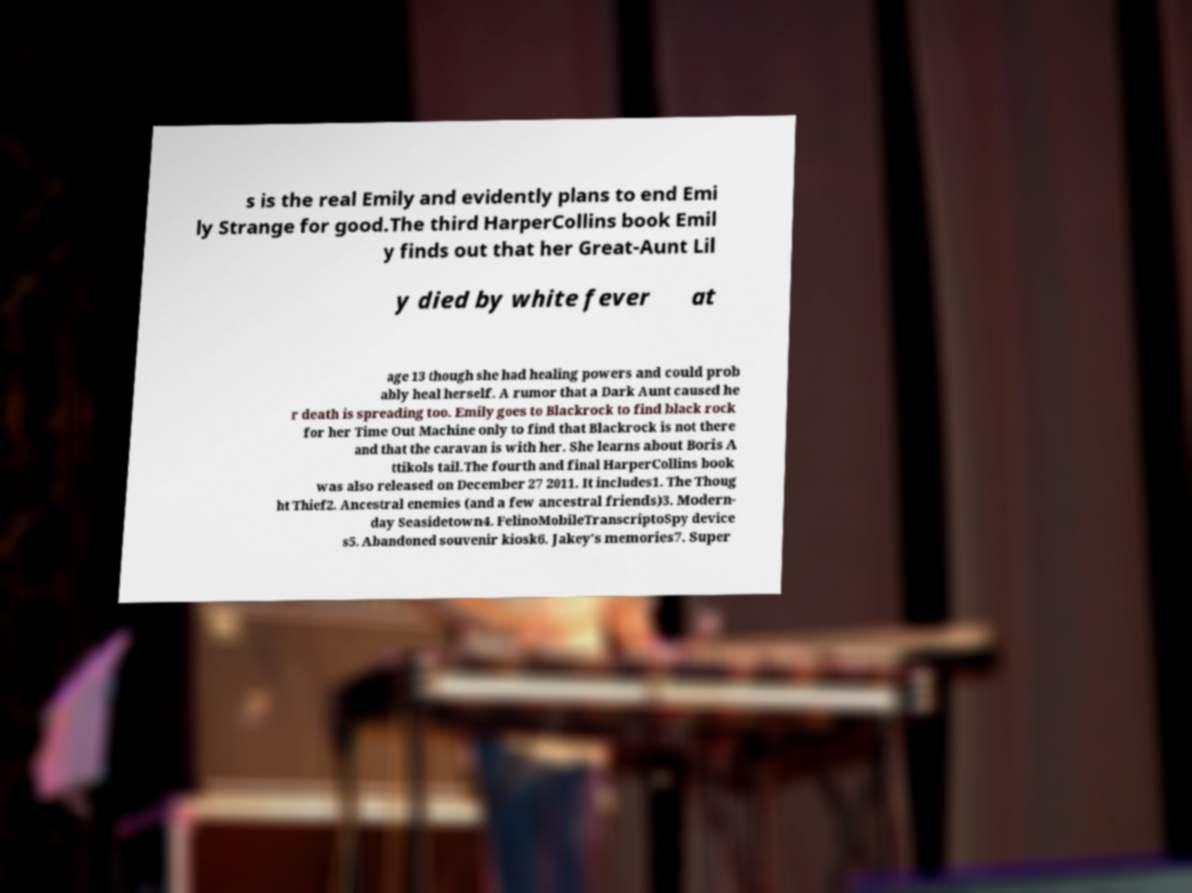For documentation purposes, I need the text within this image transcribed. Could you provide that? s is the real Emily and evidently plans to end Emi ly Strange for good.The third HarperCollins book Emil y finds out that her Great-Aunt Lil y died by white fever at age 13 though she had healing powers and could prob ably heal herself. A rumor that a Dark Aunt caused he r death is spreading too. Emily goes to Blackrock to find black rock for her Time Out Machine only to find that Blackrock is not there and that the caravan is with her. She learns about Boris A ttikols tail.The fourth and final HarperCollins book was also released on December 27 2011. It includes1. The Thoug ht Thief2. Ancestral enemies (and a few ancestral friends)3. Modern- day Seasidetown4. FelinoMobileTranscriptoSpy device s5. Abandoned souvenir kiosk6. Jakey's memories7. Super 